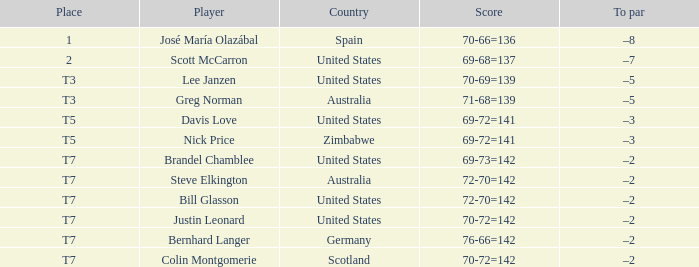Identify the player from the united states with a to par of -5. Lee Janzen. 